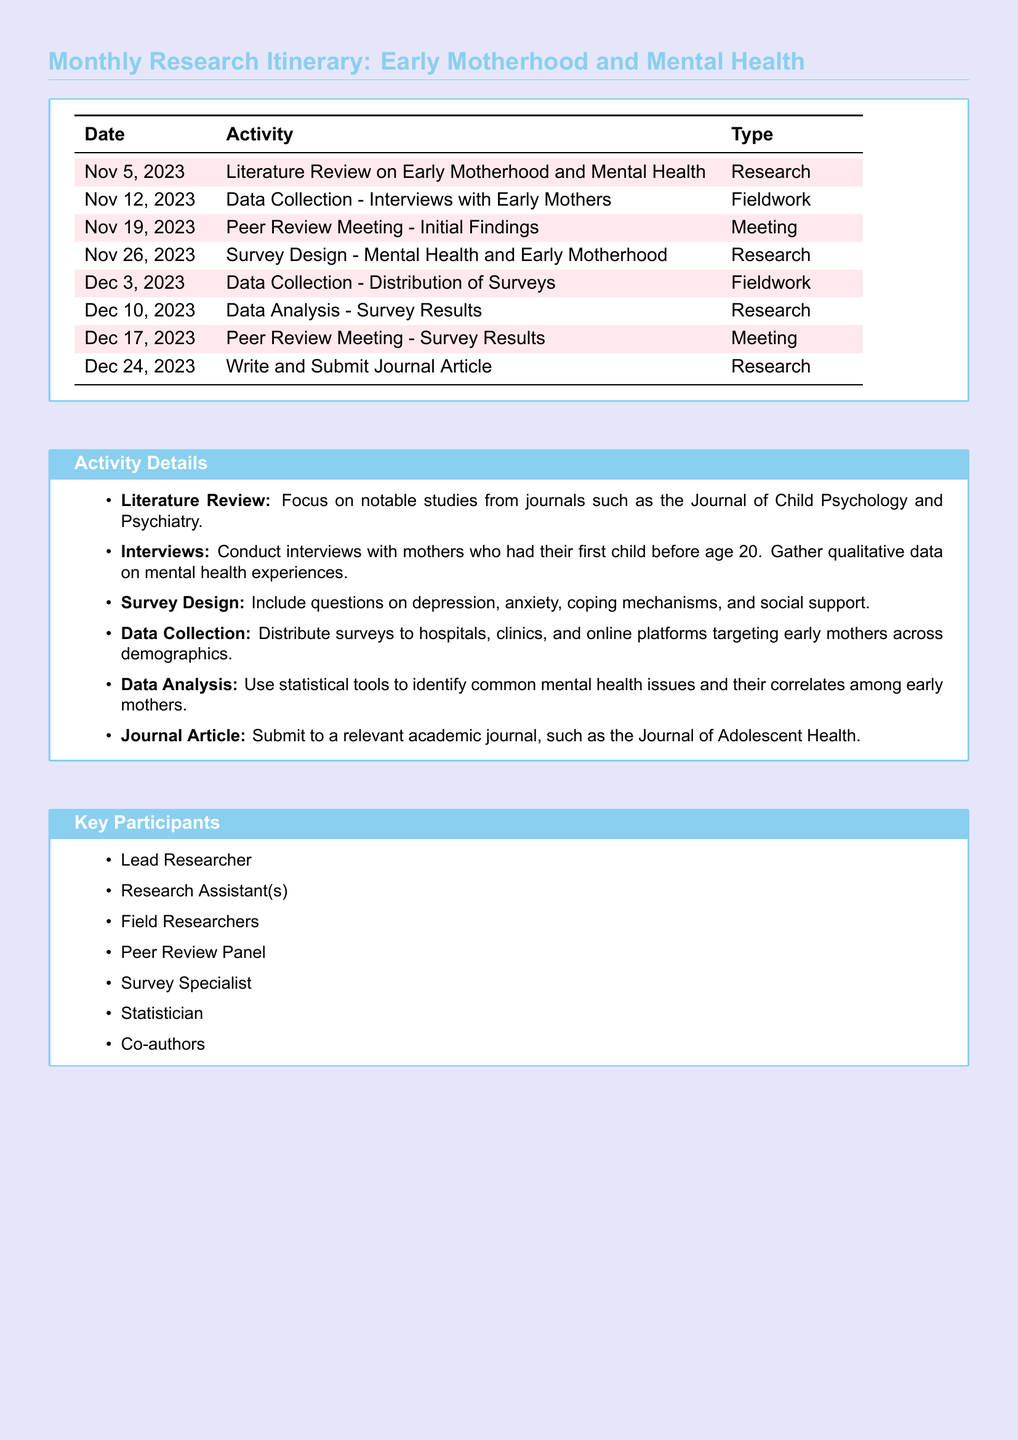What is the first activity listed in the itinerary? The first activity listed is the Literature Review on Early Motherhood and Mental Health scheduled for November 5, 2023.
Answer: Literature Review on Early Motherhood and Mental Health How many peer review meetings are scheduled in December 2023? There are two peer review meetings scheduled in December 2023, one on December 17, 2023, and another on December 17, 2023.
Answer: 2 What type of activity is scheduled for November 12, 2023? The activity scheduled for November 12, 2023, is Data Collection - Interviews with Early Mothers, which falls under Fieldwork.
Answer: Fieldwork What is the last date mentioned in the itinerary? The last date mentioned in the itinerary is December 24, 2023, for writing and submitting the journal article.
Answer: December 24, 2023 Which journal is the aim to submit the findings to? The findings are aimed to be submitted to the Journal of Adolescent Health.
Answer: Journal of Adolescent Health What demographic is targeted for the survey distribution? The survey is targeted towards early mothers across demographics.
Answer: early mothers across demographics What type of analysis will be performed on the survey results? Statistical tools will be used for data analysis on the survey results.
Answer: Statistical tools What are the participants listed as part of the project? Participants include Lead Researcher, Research Assistant(s), Field Researchers, Peer Review Panel, Survey Specialist, Statistician, and Co-authors.
Answer: Lead Researcher, Research Assistant(s), Field Researchers, Peer Review Panel, Survey Specialist, Statistician, Co-authors 